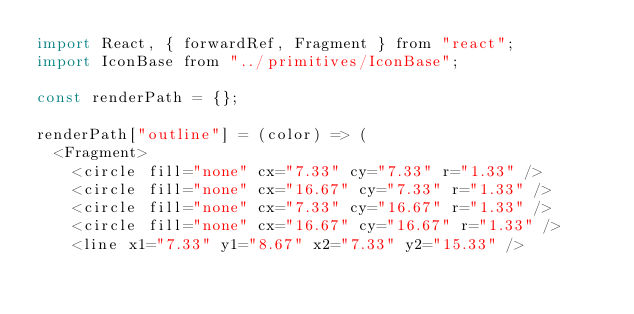<code> <loc_0><loc_0><loc_500><loc_500><_JavaScript_>import React, { forwardRef, Fragment } from "react";
import IconBase from "../primitives/IconBase";

const renderPath = {};

renderPath["outline"] = (color) => (
  <Fragment>
    <circle fill="none" cx="7.33" cy="7.33" r="1.33" />
    <circle fill="none" cx="16.67" cy="7.33" r="1.33" />
    <circle fill="none" cx="7.33" cy="16.67" r="1.33" />
    <circle fill="none" cx="16.67" cy="16.67" r="1.33" />
    <line x1="7.33" y1="8.67" x2="7.33" y2="15.33" /></code> 